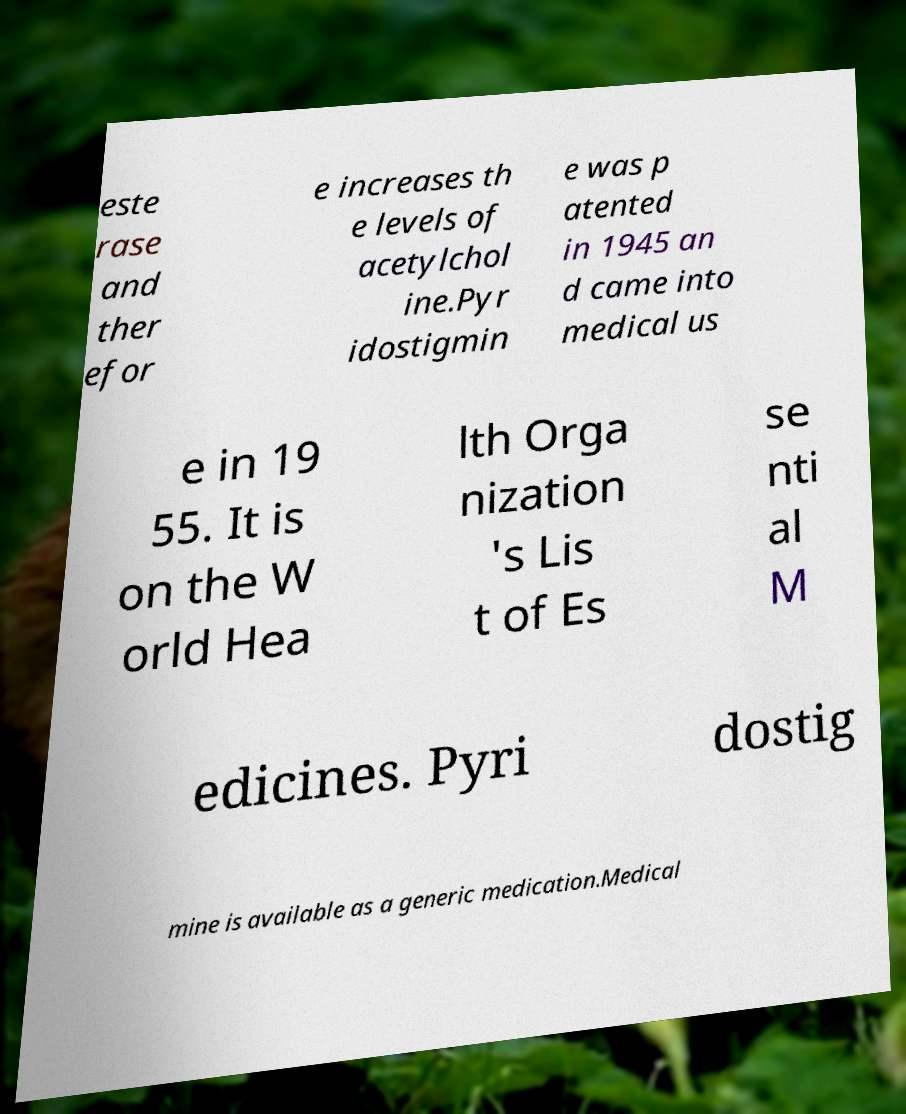For documentation purposes, I need the text within this image transcribed. Could you provide that? este rase and ther efor e increases th e levels of acetylchol ine.Pyr idostigmin e was p atented in 1945 an d came into medical us e in 19 55. It is on the W orld Hea lth Orga nization 's Lis t of Es se nti al M edicines. Pyri dostig mine is available as a generic medication.Medical 